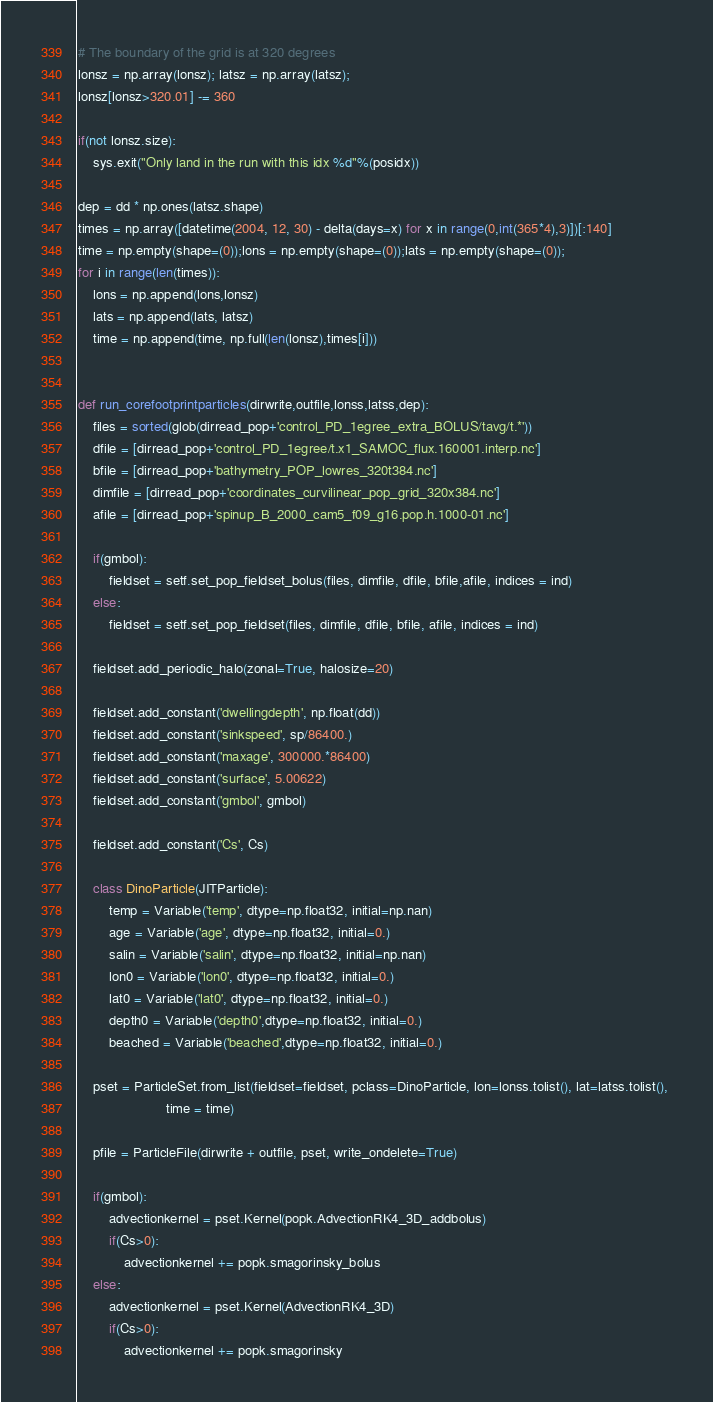<code> <loc_0><loc_0><loc_500><loc_500><_Python_>
# The boundary of the grid is at 320 degrees
lonsz = np.array(lonsz); latsz = np.array(latsz);
lonsz[lonsz>320.01] -= 360

if(not lonsz.size):
    sys.exit("Only land in the run with this idx %d"%(posidx))

dep = dd * np.ones(latsz.shape)
times = np.array([datetime(2004, 12, 30) - delta(days=x) for x in range(0,int(365*4),3)])[:140]
time = np.empty(shape=(0));lons = np.empty(shape=(0));lats = np.empty(shape=(0));
for i in range(len(times)):
    lons = np.append(lons,lonsz)
    lats = np.append(lats, latsz)
    time = np.append(time, np.full(len(lonsz),times[i])) 


def run_corefootprintparticles(dirwrite,outfile,lonss,latss,dep):
    files = sorted(glob(dirread_pop+'control_PD_1egree_extra_BOLUS/tavg/t.*'))
    dfile = [dirread_pop+'control_PD_1egree/t.x1_SAMOC_flux.160001.interp.nc']
    bfile = [dirread_pop+'bathymetry_POP_lowres_320t384.nc']
    dimfile = [dirread_pop+'coordinates_curvilinear_pop_grid_320x384.nc']
    afile = [dirread_pop+'spinup_B_2000_cam5_f09_g16.pop.h.1000-01.nc']

    if(gmbol):
        fieldset = setf.set_pop_fieldset_bolus(files, dimfile, dfile, bfile,afile, indices = ind)
    else:
        fieldset = setf.set_pop_fieldset(files, dimfile, dfile, bfile, afile, indices = ind)

    fieldset.add_periodic_halo(zonal=True, halosize=20)
       
    fieldset.add_constant('dwellingdepth', np.float(dd))
    fieldset.add_constant('sinkspeed', sp/86400.)
    fieldset.add_constant('maxage', 300000.*86400)
    fieldset.add_constant('surface', 5.00622)
    fieldset.add_constant('gmbol', gmbol)

    fieldset.add_constant('Cs', Cs)

    class DinoParticle(JITParticle):
        temp = Variable('temp', dtype=np.float32, initial=np.nan)
        age = Variable('age', dtype=np.float32, initial=0.)
        salin = Variable('salin', dtype=np.float32, initial=np.nan)
        lon0 = Variable('lon0', dtype=np.float32, initial=0.)
        lat0 = Variable('lat0', dtype=np.float32, initial=0.)
        depth0 = Variable('depth0',dtype=np.float32, initial=0.) 
        beached = Variable('beached',dtype=np.float32, initial=0.) 

    pset = ParticleSet.from_list(fieldset=fieldset, pclass=DinoParticle, lon=lonss.tolist(), lat=latss.tolist(), 
                       time = time)

    pfile = ParticleFile(dirwrite + outfile, pset, write_ondelete=True)

    if(gmbol):
        advectionkernel = pset.Kernel(popk.AdvectionRK4_3D_addbolus)
        if(Cs>0):
            advectionkernel += popk.smagorinsky_bolus
    else:
        advectionkernel = pset.Kernel(AdvectionRK4_3D)
        if(Cs>0):
            advectionkernel += popk.smagorinsky
</code> 